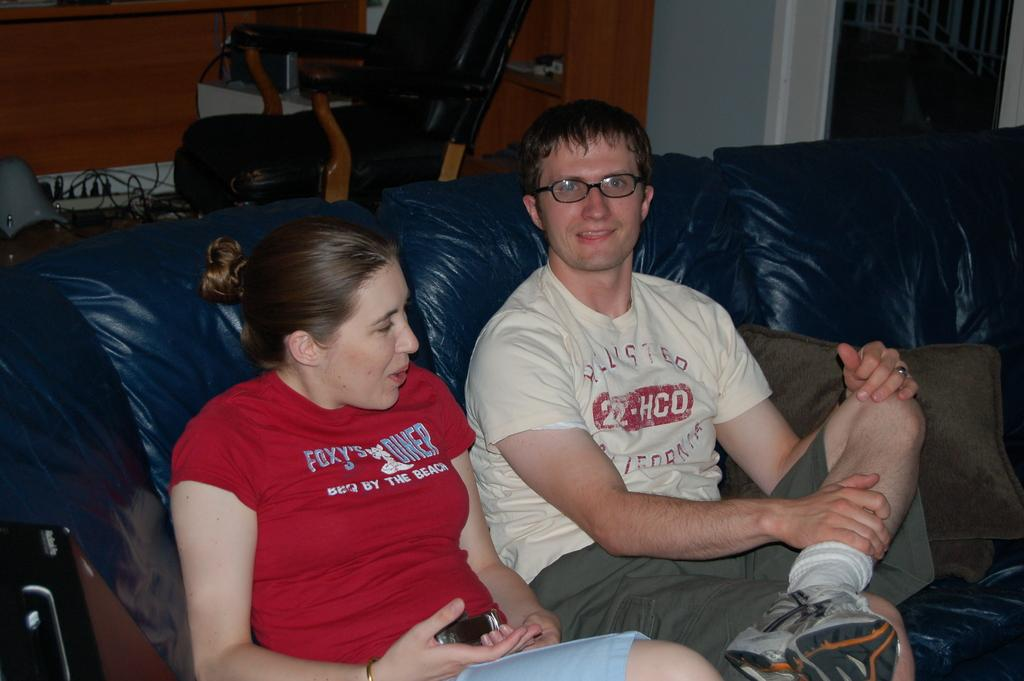How many people are in the image? There are two people in the image, a man and a woman. What are the man and woman doing in the image? Both the man and woman are sitting on a couch. What can be seen on the couch besides the man and woman? There are pillows on the couch. What other furniture is visible in the image? There is a chair in the image. What else can be seen in the image besides the people and furniture? There are cables visible in the image, and there are other objects present as well. What is the caption for the image? There is no caption present in the image. What is the weather like in the image? The weather cannot be determined from the image, as it is an indoor scene. Is there a hole visible in the image? No, there is no hole present in the image. 